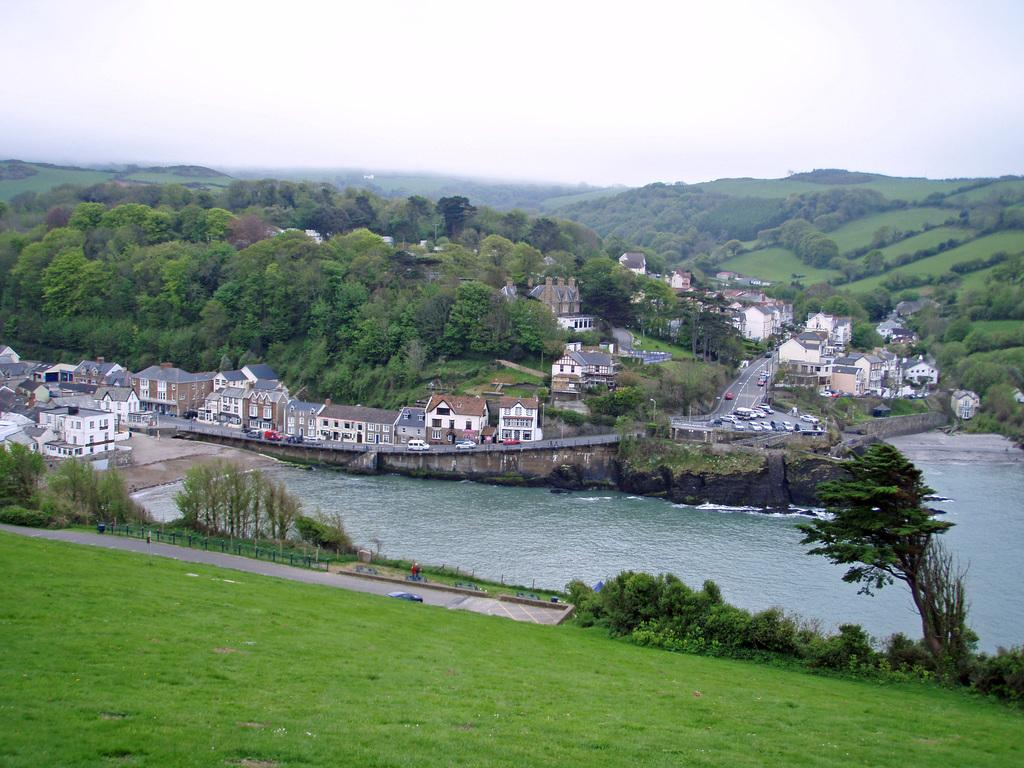What type of ground is visible in the image? There is a ground covered with grass in the image. What natural feature can be seen on the ground? There is a river on the ground. What can be seen in the distance in the image? There are buildings visible in the background of the image. What type of vegetation is present in the background of the image? There are many trees in the background of the image. How many toes can be seen on the tree in the image? There are no toes present in the image, as trees do not have toes. 